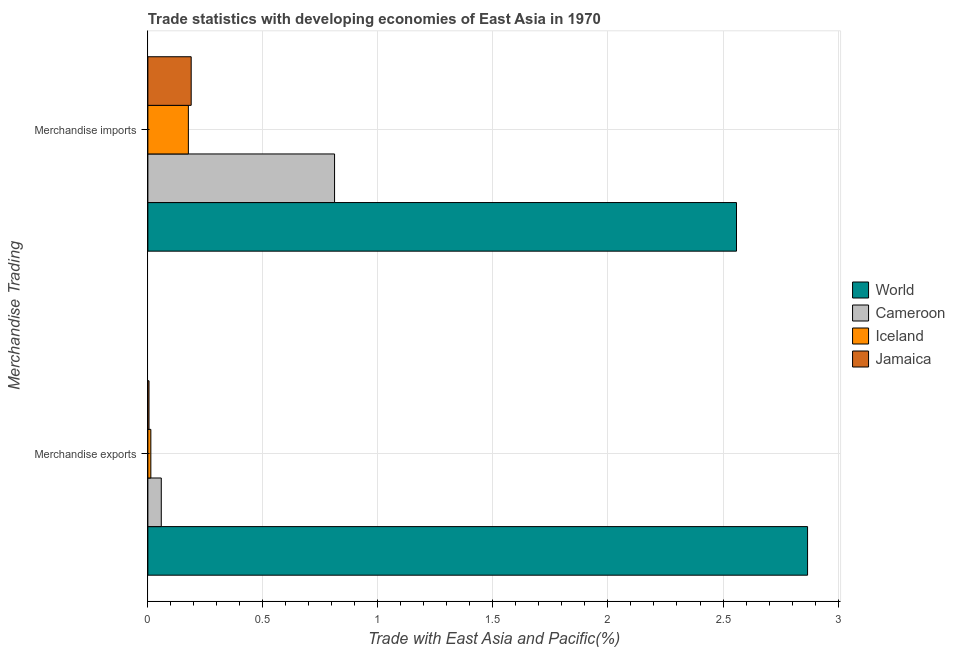How many groups of bars are there?
Make the answer very short. 2. Are the number of bars per tick equal to the number of legend labels?
Keep it short and to the point. Yes. Are the number of bars on each tick of the Y-axis equal?
Your answer should be compact. Yes. What is the merchandise exports in Cameroon?
Your response must be concise. 0.06. Across all countries, what is the maximum merchandise exports?
Your answer should be very brief. 2.87. Across all countries, what is the minimum merchandise exports?
Your response must be concise. 0. In which country was the merchandise imports maximum?
Your response must be concise. World. What is the total merchandise imports in the graph?
Offer a terse response. 3.73. What is the difference between the merchandise imports in Cameroon and that in World?
Make the answer very short. -1.75. What is the difference between the merchandise imports in World and the merchandise exports in Jamaica?
Offer a very short reply. 2.55. What is the average merchandise imports per country?
Provide a succinct answer. 0.93. What is the difference between the merchandise imports and merchandise exports in World?
Your answer should be very brief. -0.31. What is the ratio of the merchandise exports in Cameroon to that in Jamaica?
Your answer should be compact. 11.72. In how many countries, is the merchandise imports greater than the average merchandise imports taken over all countries?
Your answer should be compact. 1. What does the 3rd bar from the top in Merchandise exports represents?
Your answer should be very brief. Cameroon. What does the 3rd bar from the bottom in Merchandise exports represents?
Keep it short and to the point. Iceland. How many countries are there in the graph?
Your response must be concise. 4. Are the values on the major ticks of X-axis written in scientific E-notation?
Your answer should be very brief. No. Does the graph contain any zero values?
Offer a very short reply. No. Where does the legend appear in the graph?
Ensure brevity in your answer.  Center right. How many legend labels are there?
Your response must be concise. 4. What is the title of the graph?
Your answer should be compact. Trade statistics with developing economies of East Asia in 1970. What is the label or title of the X-axis?
Make the answer very short. Trade with East Asia and Pacific(%). What is the label or title of the Y-axis?
Keep it short and to the point. Merchandise Trading. What is the Trade with East Asia and Pacific(%) in World in Merchandise exports?
Make the answer very short. 2.87. What is the Trade with East Asia and Pacific(%) of Cameroon in Merchandise exports?
Your response must be concise. 0.06. What is the Trade with East Asia and Pacific(%) of Iceland in Merchandise exports?
Make the answer very short. 0.01. What is the Trade with East Asia and Pacific(%) of Jamaica in Merchandise exports?
Ensure brevity in your answer.  0. What is the Trade with East Asia and Pacific(%) of World in Merchandise imports?
Your response must be concise. 2.56. What is the Trade with East Asia and Pacific(%) of Cameroon in Merchandise imports?
Ensure brevity in your answer.  0.81. What is the Trade with East Asia and Pacific(%) in Iceland in Merchandise imports?
Make the answer very short. 0.18. What is the Trade with East Asia and Pacific(%) in Jamaica in Merchandise imports?
Your answer should be very brief. 0.19. Across all Merchandise Trading, what is the maximum Trade with East Asia and Pacific(%) in World?
Offer a very short reply. 2.87. Across all Merchandise Trading, what is the maximum Trade with East Asia and Pacific(%) of Cameroon?
Offer a terse response. 0.81. Across all Merchandise Trading, what is the maximum Trade with East Asia and Pacific(%) of Iceland?
Your response must be concise. 0.18. Across all Merchandise Trading, what is the maximum Trade with East Asia and Pacific(%) in Jamaica?
Ensure brevity in your answer.  0.19. Across all Merchandise Trading, what is the minimum Trade with East Asia and Pacific(%) in World?
Ensure brevity in your answer.  2.56. Across all Merchandise Trading, what is the minimum Trade with East Asia and Pacific(%) of Cameroon?
Your answer should be compact. 0.06. Across all Merchandise Trading, what is the minimum Trade with East Asia and Pacific(%) of Iceland?
Keep it short and to the point. 0.01. Across all Merchandise Trading, what is the minimum Trade with East Asia and Pacific(%) in Jamaica?
Provide a short and direct response. 0. What is the total Trade with East Asia and Pacific(%) in World in the graph?
Give a very brief answer. 5.43. What is the total Trade with East Asia and Pacific(%) in Cameroon in the graph?
Provide a succinct answer. 0.87. What is the total Trade with East Asia and Pacific(%) of Iceland in the graph?
Ensure brevity in your answer.  0.19. What is the total Trade with East Asia and Pacific(%) in Jamaica in the graph?
Your response must be concise. 0.19. What is the difference between the Trade with East Asia and Pacific(%) in World in Merchandise exports and that in Merchandise imports?
Make the answer very short. 0.31. What is the difference between the Trade with East Asia and Pacific(%) of Cameroon in Merchandise exports and that in Merchandise imports?
Offer a terse response. -0.75. What is the difference between the Trade with East Asia and Pacific(%) in Iceland in Merchandise exports and that in Merchandise imports?
Make the answer very short. -0.16. What is the difference between the Trade with East Asia and Pacific(%) in Jamaica in Merchandise exports and that in Merchandise imports?
Your response must be concise. -0.18. What is the difference between the Trade with East Asia and Pacific(%) in World in Merchandise exports and the Trade with East Asia and Pacific(%) in Cameroon in Merchandise imports?
Ensure brevity in your answer.  2.06. What is the difference between the Trade with East Asia and Pacific(%) of World in Merchandise exports and the Trade with East Asia and Pacific(%) of Iceland in Merchandise imports?
Provide a short and direct response. 2.69. What is the difference between the Trade with East Asia and Pacific(%) of World in Merchandise exports and the Trade with East Asia and Pacific(%) of Jamaica in Merchandise imports?
Offer a very short reply. 2.68. What is the difference between the Trade with East Asia and Pacific(%) in Cameroon in Merchandise exports and the Trade with East Asia and Pacific(%) in Iceland in Merchandise imports?
Ensure brevity in your answer.  -0.12. What is the difference between the Trade with East Asia and Pacific(%) in Cameroon in Merchandise exports and the Trade with East Asia and Pacific(%) in Jamaica in Merchandise imports?
Your answer should be compact. -0.13. What is the difference between the Trade with East Asia and Pacific(%) in Iceland in Merchandise exports and the Trade with East Asia and Pacific(%) in Jamaica in Merchandise imports?
Ensure brevity in your answer.  -0.18. What is the average Trade with East Asia and Pacific(%) in World per Merchandise Trading?
Your answer should be compact. 2.71. What is the average Trade with East Asia and Pacific(%) of Cameroon per Merchandise Trading?
Your answer should be very brief. 0.43. What is the average Trade with East Asia and Pacific(%) of Iceland per Merchandise Trading?
Offer a very short reply. 0.09. What is the average Trade with East Asia and Pacific(%) in Jamaica per Merchandise Trading?
Give a very brief answer. 0.1. What is the difference between the Trade with East Asia and Pacific(%) in World and Trade with East Asia and Pacific(%) in Cameroon in Merchandise exports?
Give a very brief answer. 2.81. What is the difference between the Trade with East Asia and Pacific(%) in World and Trade with East Asia and Pacific(%) in Iceland in Merchandise exports?
Offer a terse response. 2.85. What is the difference between the Trade with East Asia and Pacific(%) in World and Trade with East Asia and Pacific(%) in Jamaica in Merchandise exports?
Offer a terse response. 2.86. What is the difference between the Trade with East Asia and Pacific(%) of Cameroon and Trade with East Asia and Pacific(%) of Iceland in Merchandise exports?
Ensure brevity in your answer.  0.05. What is the difference between the Trade with East Asia and Pacific(%) in Cameroon and Trade with East Asia and Pacific(%) in Jamaica in Merchandise exports?
Offer a terse response. 0.05. What is the difference between the Trade with East Asia and Pacific(%) in Iceland and Trade with East Asia and Pacific(%) in Jamaica in Merchandise exports?
Provide a short and direct response. 0.01. What is the difference between the Trade with East Asia and Pacific(%) of World and Trade with East Asia and Pacific(%) of Cameroon in Merchandise imports?
Your answer should be very brief. 1.75. What is the difference between the Trade with East Asia and Pacific(%) in World and Trade with East Asia and Pacific(%) in Iceland in Merchandise imports?
Ensure brevity in your answer.  2.38. What is the difference between the Trade with East Asia and Pacific(%) of World and Trade with East Asia and Pacific(%) of Jamaica in Merchandise imports?
Offer a terse response. 2.37. What is the difference between the Trade with East Asia and Pacific(%) of Cameroon and Trade with East Asia and Pacific(%) of Iceland in Merchandise imports?
Offer a very short reply. 0.64. What is the difference between the Trade with East Asia and Pacific(%) in Cameroon and Trade with East Asia and Pacific(%) in Jamaica in Merchandise imports?
Ensure brevity in your answer.  0.62. What is the difference between the Trade with East Asia and Pacific(%) in Iceland and Trade with East Asia and Pacific(%) in Jamaica in Merchandise imports?
Your answer should be compact. -0.01. What is the ratio of the Trade with East Asia and Pacific(%) of World in Merchandise exports to that in Merchandise imports?
Provide a succinct answer. 1.12. What is the ratio of the Trade with East Asia and Pacific(%) of Cameroon in Merchandise exports to that in Merchandise imports?
Provide a short and direct response. 0.07. What is the ratio of the Trade with East Asia and Pacific(%) of Iceland in Merchandise exports to that in Merchandise imports?
Your answer should be compact. 0.07. What is the ratio of the Trade with East Asia and Pacific(%) of Jamaica in Merchandise exports to that in Merchandise imports?
Ensure brevity in your answer.  0.03. What is the difference between the highest and the second highest Trade with East Asia and Pacific(%) in World?
Keep it short and to the point. 0.31. What is the difference between the highest and the second highest Trade with East Asia and Pacific(%) in Cameroon?
Offer a very short reply. 0.75. What is the difference between the highest and the second highest Trade with East Asia and Pacific(%) in Iceland?
Offer a very short reply. 0.16. What is the difference between the highest and the second highest Trade with East Asia and Pacific(%) in Jamaica?
Your answer should be compact. 0.18. What is the difference between the highest and the lowest Trade with East Asia and Pacific(%) of World?
Your answer should be compact. 0.31. What is the difference between the highest and the lowest Trade with East Asia and Pacific(%) in Cameroon?
Offer a terse response. 0.75. What is the difference between the highest and the lowest Trade with East Asia and Pacific(%) of Iceland?
Offer a terse response. 0.16. What is the difference between the highest and the lowest Trade with East Asia and Pacific(%) in Jamaica?
Offer a terse response. 0.18. 